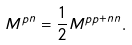Convert formula to latex. <formula><loc_0><loc_0><loc_500><loc_500>M ^ { p n } = \frac { 1 } { 2 } M ^ { p p + n n } .</formula> 